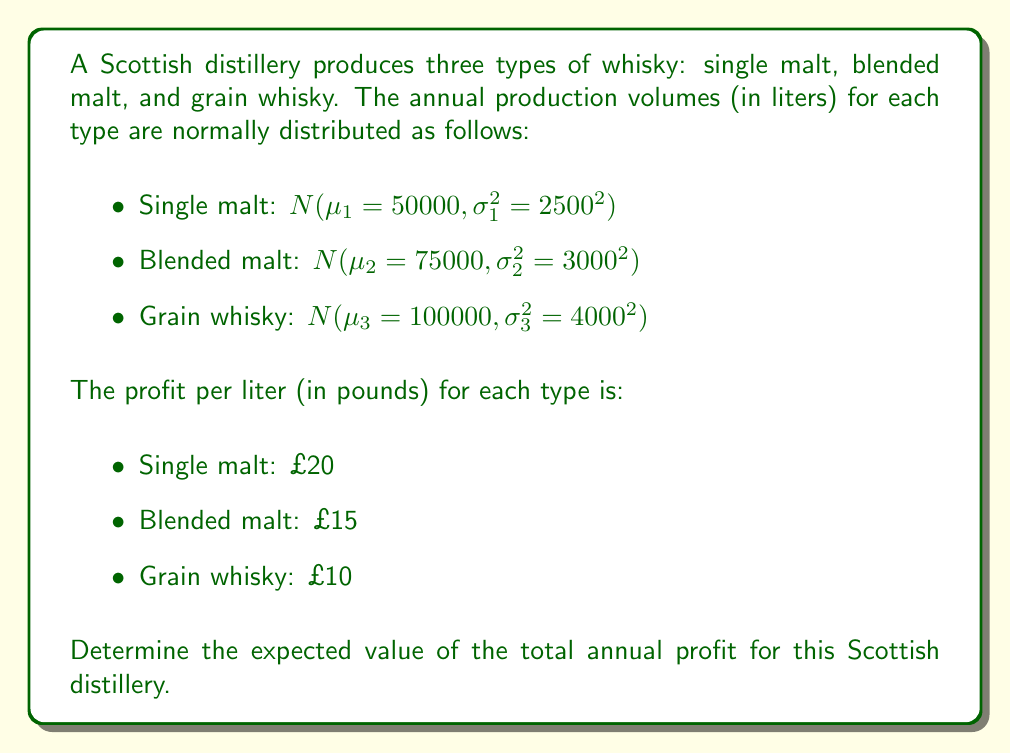Solve this math problem. To solve this problem, we need to follow these steps:

1) First, recall that the expected value of a constant times a random variable is the constant times the expected value of the random variable. That is, $E[aX] = aE[X]$.

2) For each type of whisky, we need to calculate the expected profit:

   For single malt:
   $E[Profit_{single}] = 20 \cdot E[Volume_{single}] = 20 \cdot 50000 = 1000000$

   For blended malt:
   $E[Profit_{blended}] = 15 \cdot E[Volume_{blended}] = 15 \cdot 75000 = 1125000$

   For grain whisky:
   $E[Profit_{grain}] = 10 \cdot E[Volume_{grain}] = 10 \cdot 100000 = 1000000$

3) The total expected profit is the sum of the expected profits for each type:

   $E[Profit_{total}] = E[Profit_{single}] + E[Profit_{blended}] + E[Profit_{grain}]$

4) Substituting the values:

   $E[Profit_{total}] = 1000000 + 1125000 + 1000000 = 3125000$

Therefore, the expected value of the total annual profit is £3,125,000.

Note: The standard deviations given in the problem are not needed for calculating the expected value. They would be used if we needed to calculate probabilities or intervals related to the profit.
Answer: £3,125,000 